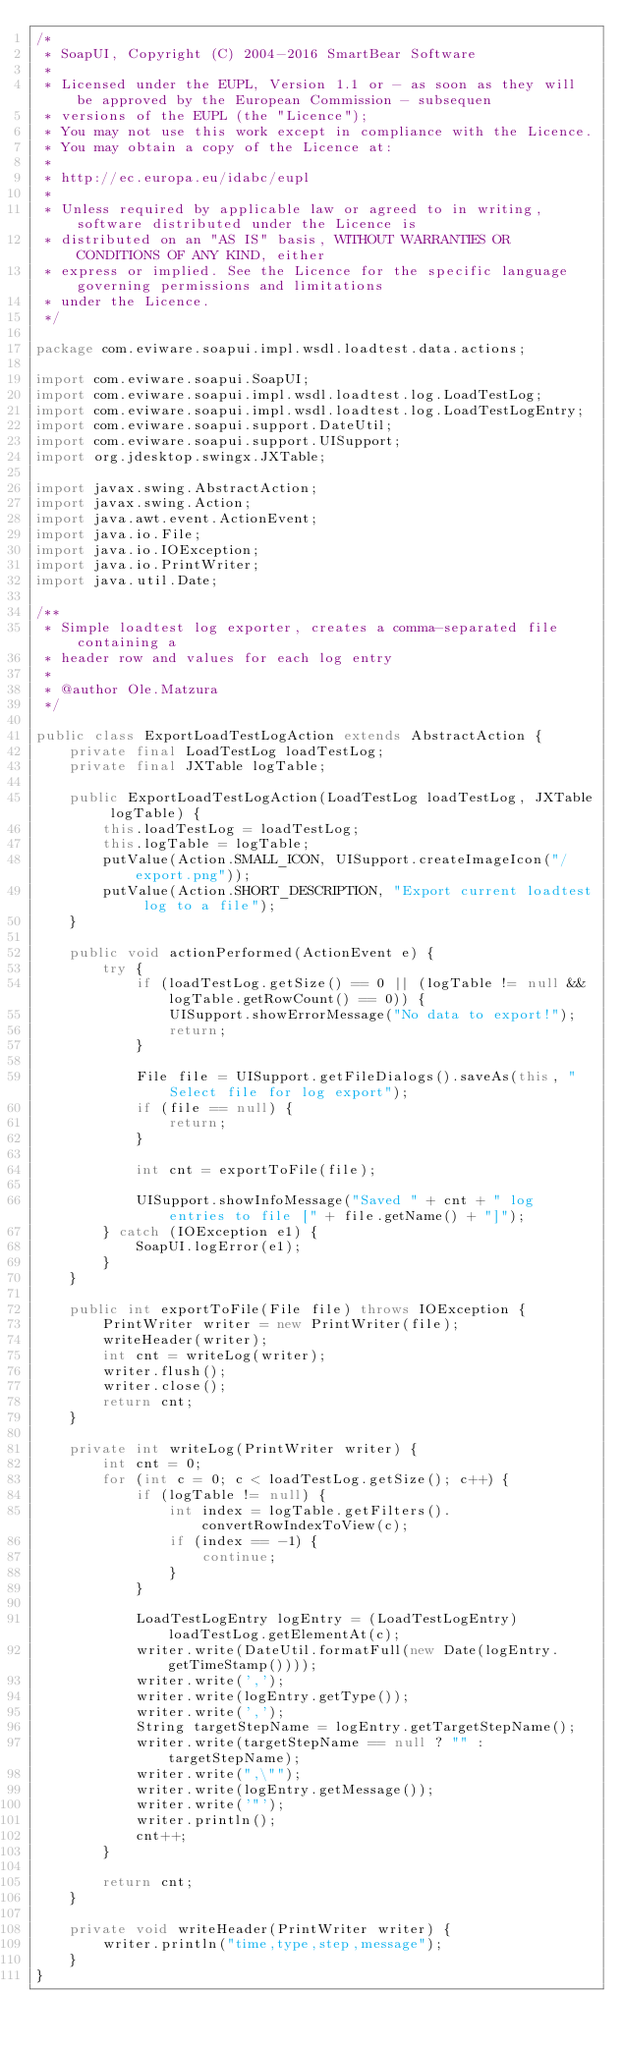Convert code to text. <code><loc_0><loc_0><loc_500><loc_500><_Java_>/*
 * SoapUI, Copyright (C) 2004-2016 SmartBear Software
 *
 * Licensed under the EUPL, Version 1.1 or - as soon as they will be approved by the European Commission - subsequen
 * versions of the EUPL (the "Licence");
 * You may not use this work except in compliance with the Licence.
 * You may obtain a copy of the Licence at:
 *
 * http://ec.europa.eu/idabc/eupl
 *
 * Unless required by applicable law or agreed to in writing, software distributed under the Licence is
 * distributed on an "AS IS" basis, WITHOUT WARRANTIES OR CONDITIONS OF ANY KIND, either
 * express or implied. See the Licence for the specific language governing permissions and limitations
 * under the Licence.
 */

package com.eviware.soapui.impl.wsdl.loadtest.data.actions;

import com.eviware.soapui.SoapUI;
import com.eviware.soapui.impl.wsdl.loadtest.log.LoadTestLog;
import com.eviware.soapui.impl.wsdl.loadtest.log.LoadTestLogEntry;
import com.eviware.soapui.support.DateUtil;
import com.eviware.soapui.support.UISupport;
import org.jdesktop.swingx.JXTable;

import javax.swing.AbstractAction;
import javax.swing.Action;
import java.awt.event.ActionEvent;
import java.io.File;
import java.io.IOException;
import java.io.PrintWriter;
import java.util.Date;

/**
 * Simple loadtest log exporter, creates a comma-separated file containing a
 * header row and values for each log entry
 *
 * @author Ole.Matzura
 */

public class ExportLoadTestLogAction extends AbstractAction {
    private final LoadTestLog loadTestLog;
    private final JXTable logTable;

    public ExportLoadTestLogAction(LoadTestLog loadTestLog, JXTable logTable) {
        this.loadTestLog = loadTestLog;
        this.logTable = logTable;
        putValue(Action.SMALL_ICON, UISupport.createImageIcon("/export.png"));
        putValue(Action.SHORT_DESCRIPTION, "Export current loadtest log to a file");
    }

    public void actionPerformed(ActionEvent e) {
        try {
            if (loadTestLog.getSize() == 0 || (logTable != null && logTable.getRowCount() == 0)) {
                UISupport.showErrorMessage("No data to export!");
                return;
            }

            File file = UISupport.getFileDialogs().saveAs(this, "Select file for log export");
            if (file == null) {
                return;
            }

            int cnt = exportToFile(file);

            UISupport.showInfoMessage("Saved " + cnt + " log entries to file [" + file.getName() + "]");
        } catch (IOException e1) {
            SoapUI.logError(e1);
        }
    }

    public int exportToFile(File file) throws IOException {
        PrintWriter writer = new PrintWriter(file);
        writeHeader(writer);
        int cnt = writeLog(writer);
        writer.flush();
        writer.close();
        return cnt;
    }

    private int writeLog(PrintWriter writer) {
        int cnt = 0;
        for (int c = 0; c < loadTestLog.getSize(); c++) {
            if (logTable != null) {
                int index = logTable.getFilters().convertRowIndexToView(c);
                if (index == -1) {
                    continue;
                }
            }

            LoadTestLogEntry logEntry = (LoadTestLogEntry) loadTestLog.getElementAt(c);
            writer.write(DateUtil.formatFull(new Date(logEntry.getTimeStamp())));
            writer.write(',');
            writer.write(logEntry.getType());
            writer.write(',');
            String targetStepName = logEntry.getTargetStepName();
            writer.write(targetStepName == null ? "" : targetStepName);
            writer.write(",\"");
            writer.write(logEntry.getMessage());
            writer.write('"');
            writer.println();
            cnt++;
        }

        return cnt;
    }

    private void writeHeader(PrintWriter writer) {
        writer.println("time,type,step,message");
    }
}
</code> 